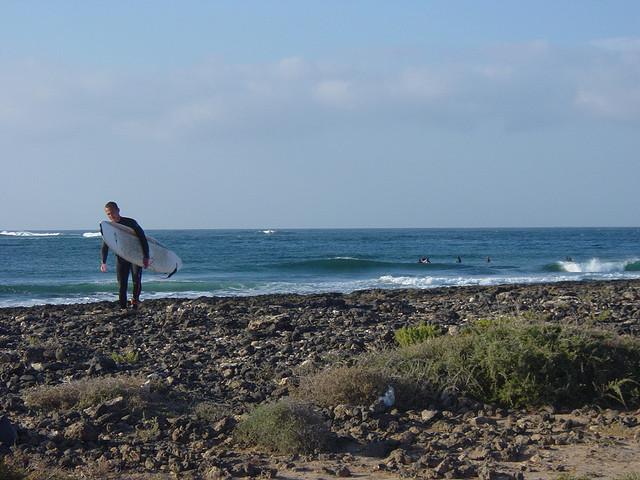What the man is doing?
Answer briefly. Walking. What color is the water?
Short answer required. Blue. Do the waves look fun to surf?
Keep it brief. Yes. Is the sand soft?
Short answer required. No. What is the person looking at?
Write a very short answer. Ground. Is the person a man or a woman?
Give a very brief answer. Man. How many people are there?
Quick response, please. 1. How do his feet probably feel right now?
Short answer required. Sore. Are there rocks in this picture?
Give a very brief answer. Yes. What is the person holding?
Answer briefly. Surfboard. Is it low tide or high tide?
Be succinct. Low. What is covering the ground?
Quick response, please. Rocks. Does the rocks have a green substance growing on them?
Write a very short answer. Yes. What is the man doing?
Quick response, please. Walking. Does the bodysuit cover the legs?
Short answer required. Yes. Is the surfer alone at the beach?
Short answer required. Yes. What is in the sky?
Write a very short answer. Clouds. Is the person standing or sitting?
Short answer required. Standing. Is the water calm?
Keep it brief. Yes. Where are the people?
Answer briefly. Beach. Are there people in the picture?
Short answer required. Yes. Is this a sandy beach?
Give a very brief answer. No. Is the guy wearing headphones?
Answer briefly. No. What is he holding?
Short answer required. Surfboard. Why are there waves in the water?
Short answer required. Wind. What are the people doing?
Short answer required. Surfing. Would this be a good beach for beachcombing?
Keep it brief. Yes. 